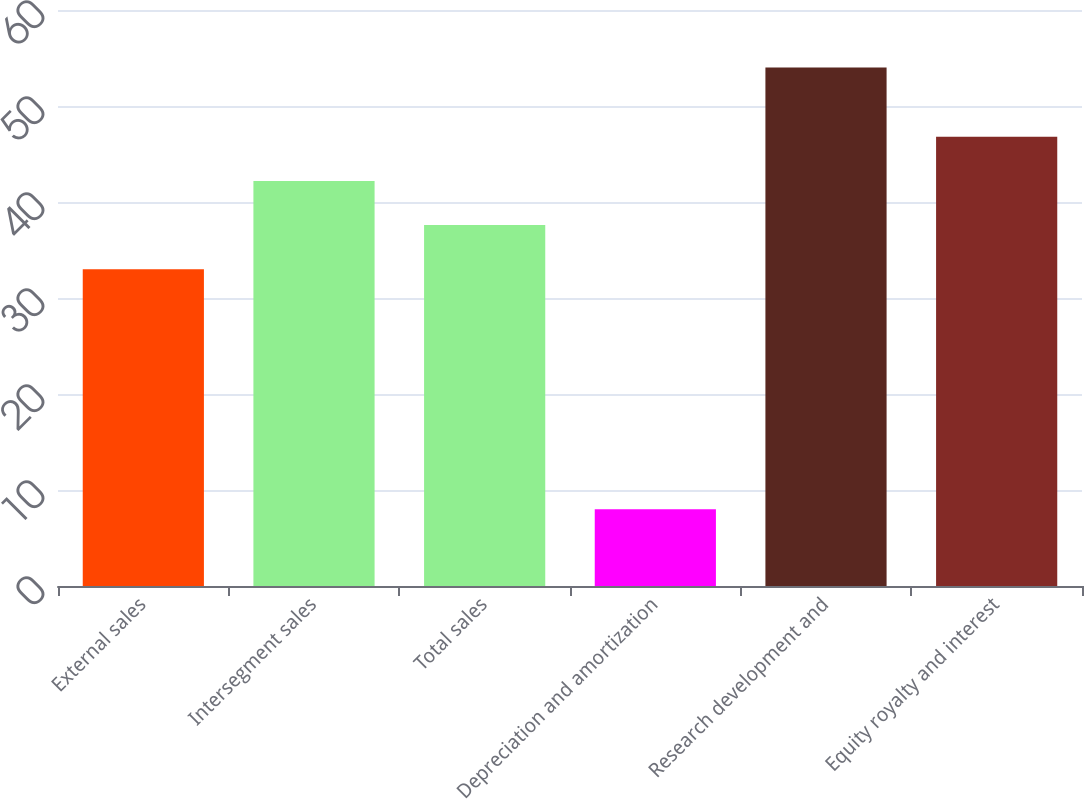Convert chart to OTSL. <chart><loc_0><loc_0><loc_500><loc_500><bar_chart><fcel>External sales<fcel>Intersegment sales<fcel>Total sales<fcel>Depreciation and amortization<fcel>Research development and<fcel>Equity royalty and interest<nl><fcel>33<fcel>42.2<fcel>37.6<fcel>8<fcel>54<fcel>46.8<nl></chart> 